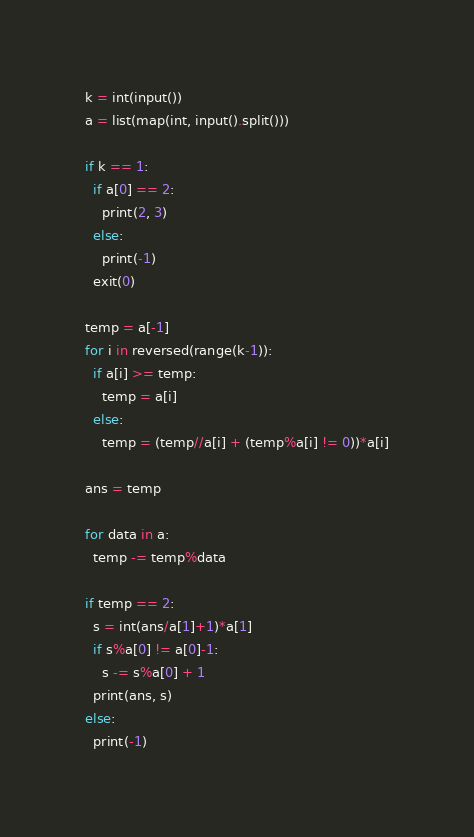Convert code to text. <code><loc_0><loc_0><loc_500><loc_500><_Python_>k = int(input())
a = list(map(int, input().split()))

if k == 1:
  if a[0] == 2:
    print(2, 3)
  else:
    print(-1)
  exit(0)

temp = a[-1]
for i in reversed(range(k-1)):
  if a[i] >= temp:
    temp = a[i]
  else:
    temp = (temp//a[i] + (temp%a[i] != 0))*a[i]

ans = temp

for data in a:
  temp -= temp%data

if temp == 2:
  s = int(ans/a[1]+1)*a[1]
  if s%a[0] != a[0]-1:
    s -= s%a[0] + 1
  print(ans, s)
else:
  print(-1)

</code> 